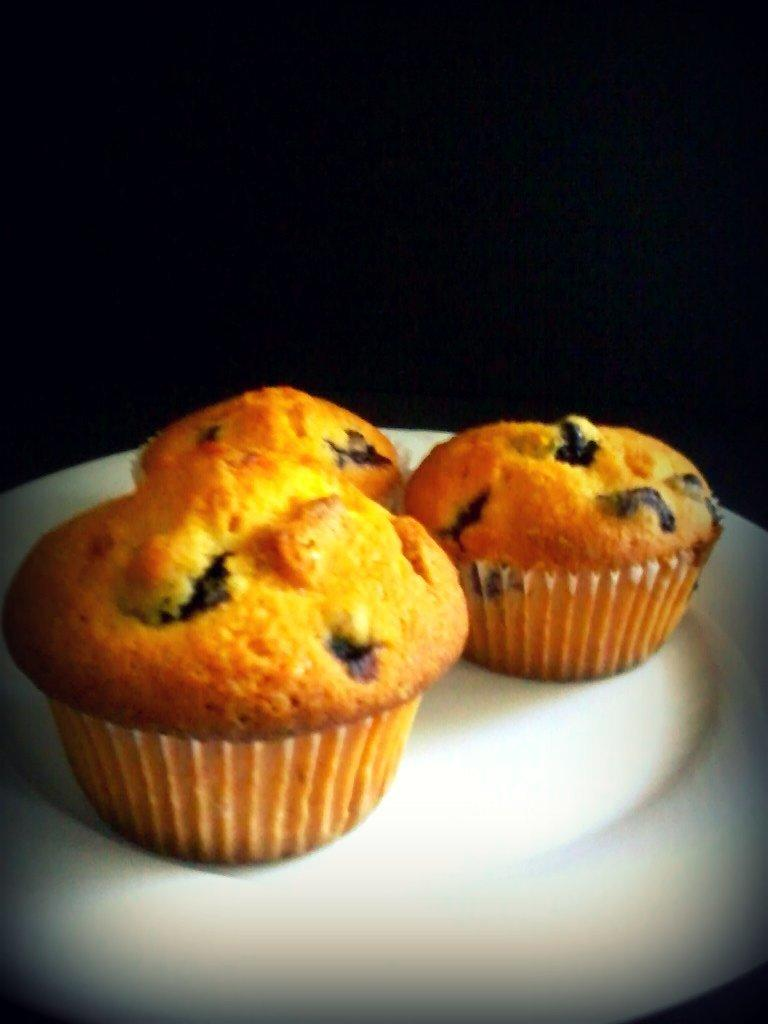How many cupcakes are visible in the image? There are three cupcakes in the image. Where are the cupcakes placed? The cupcakes are placed on a white plate. What is the color of the background in the image? The background in the image is black. What type of fuel is being used by the cupcakes in the image? Cupcakes do not use fuel, so this question cannot be answered based on the image. 